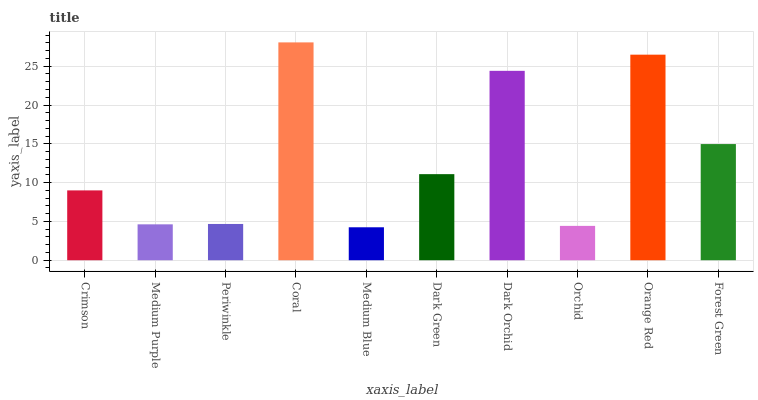Is Medium Purple the minimum?
Answer yes or no. No. Is Medium Purple the maximum?
Answer yes or no. No. Is Crimson greater than Medium Purple?
Answer yes or no. Yes. Is Medium Purple less than Crimson?
Answer yes or no. Yes. Is Medium Purple greater than Crimson?
Answer yes or no. No. Is Crimson less than Medium Purple?
Answer yes or no. No. Is Dark Green the high median?
Answer yes or no. Yes. Is Crimson the low median?
Answer yes or no. Yes. Is Orchid the high median?
Answer yes or no. No. Is Medium Purple the low median?
Answer yes or no. No. 